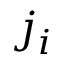Convert formula to latex. <formula><loc_0><loc_0><loc_500><loc_500>j _ { i }</formula> 